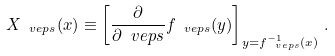Convert formula to latex. <formula><loc_0><loc_0><loc_500><loc_500>X _ { \ v e p s } ( x ) \equiv \left [ \frac { \partial } { \partial \ v e p s } f _ { \ v e p s } ( y ) \right ] _ { y = f _ { \ v e p s } ^ { - 1 } ( x ) } \, .</formula> 